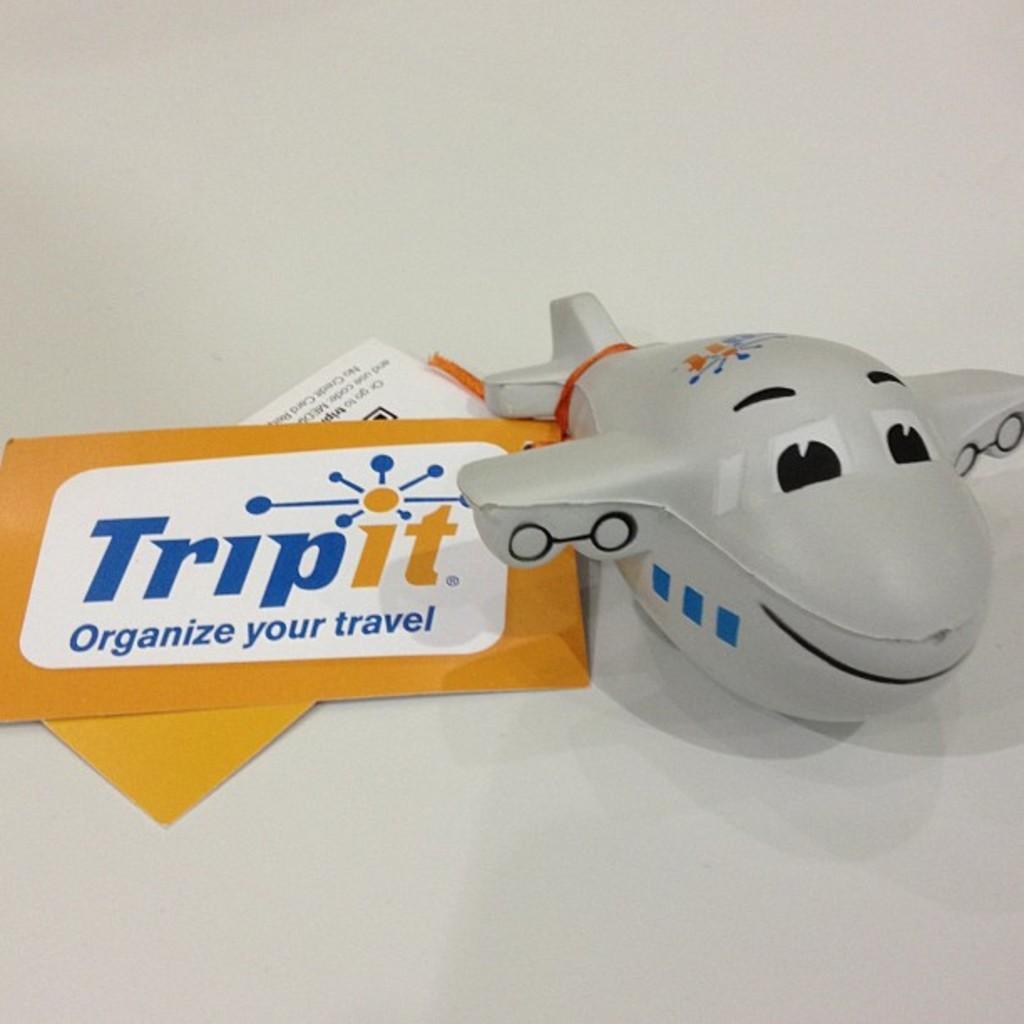What does the card say on the left?
Give a very brief answer. Trip it organize your travel. 